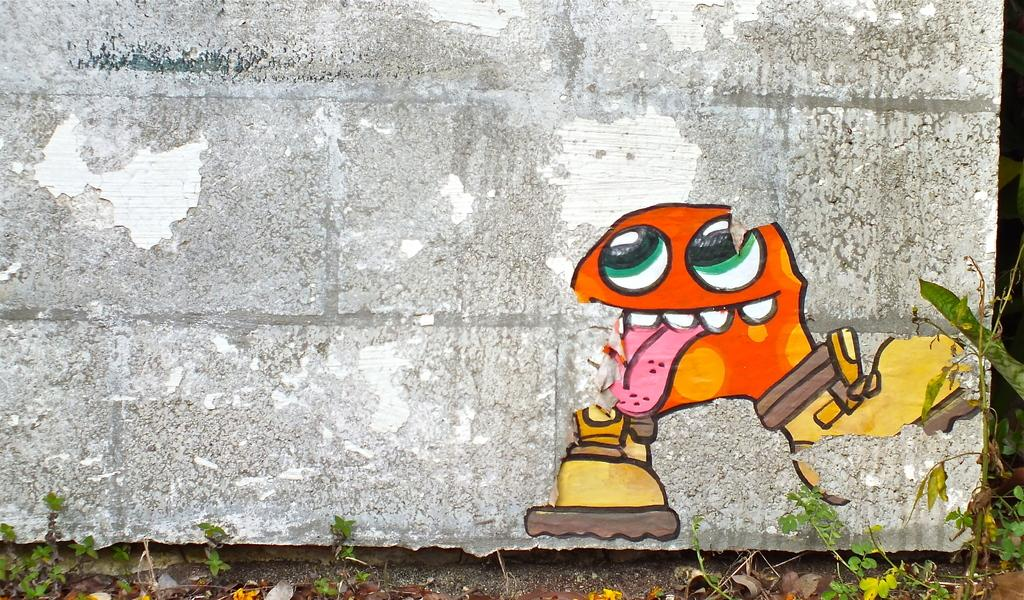What is depicted on the wall in the image? There is a painting on a wall in the image. What else can be seen in the image besides the painting? There are plants in the image. Can you tell me how many robins are perched on the painting in the image? There are no robins present in the image; it features a painting and plants. What type of adjustment is being made to the painting in the image? There is no adjustment being made to the painting in the image; it is a static image of a painting and plants. 